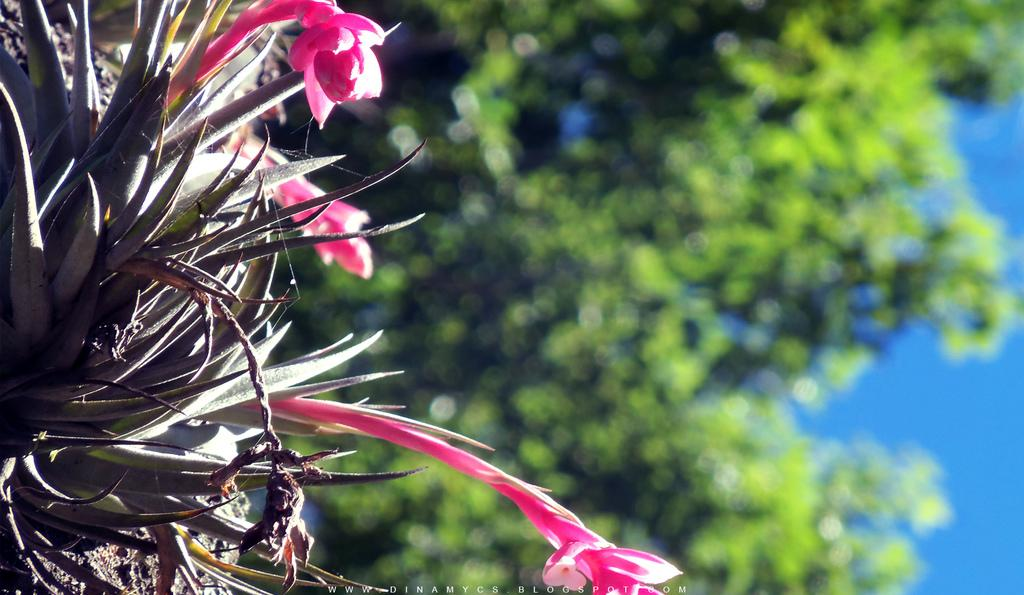What is present in the picture? There is a plant in the picture. Can you describe the plant's flowers? The plant has pink flowers. What can be seen in the background of the picture? There are trees in the background of the picture. Where is the goat located in the picture? There is no goat present in the picture; it only features a plant with pink flowers and trees in the background. Can you tell me how many rabbits are hiding among the flowers? There are no rabbits present in the picture; it only features a plant with pink flowers and trees in the background. 